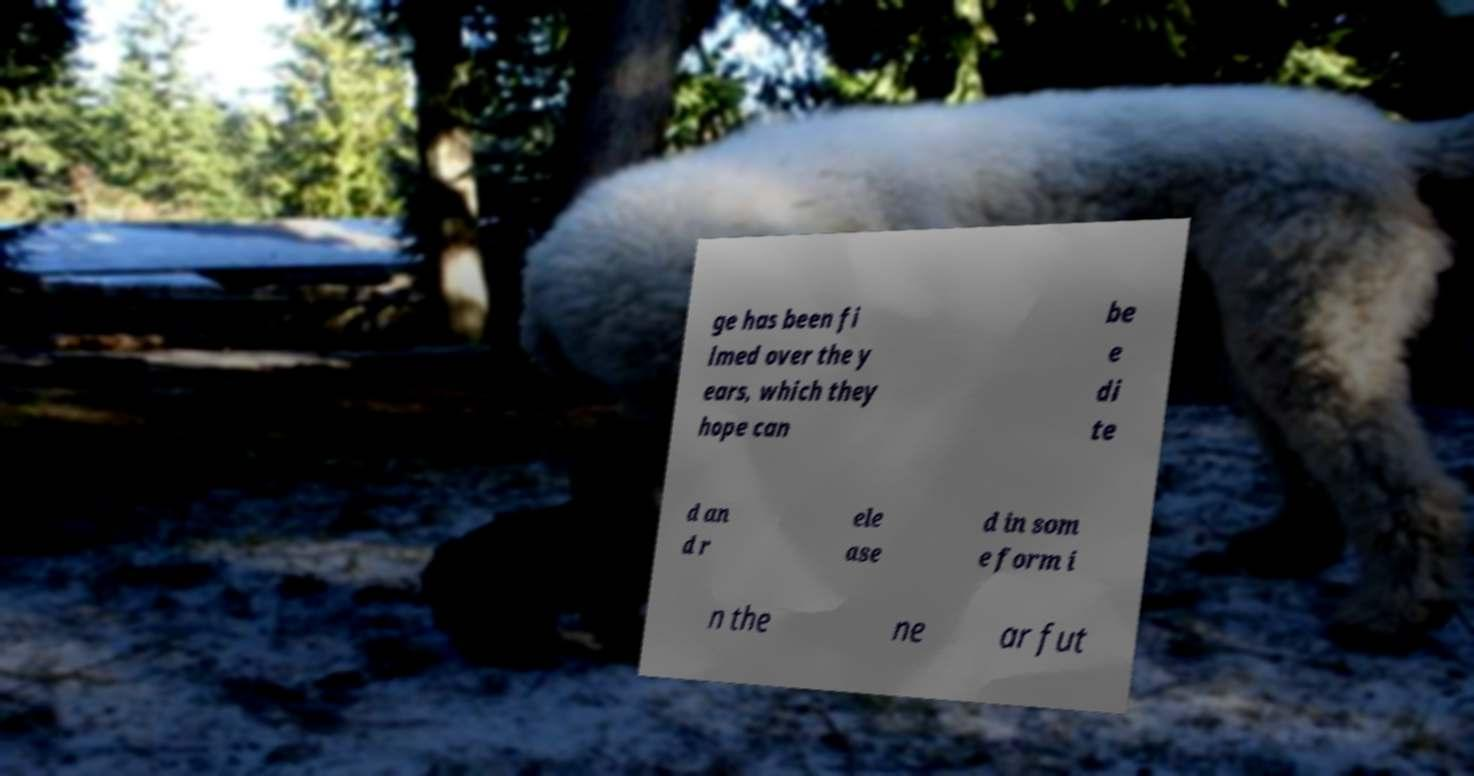Can you accurately transcribe the text from the provided image for me? ge has been fi lmed over the y ears, which they hope can be e di te d an d r ele ase d in som e form i n the ne ar fut 